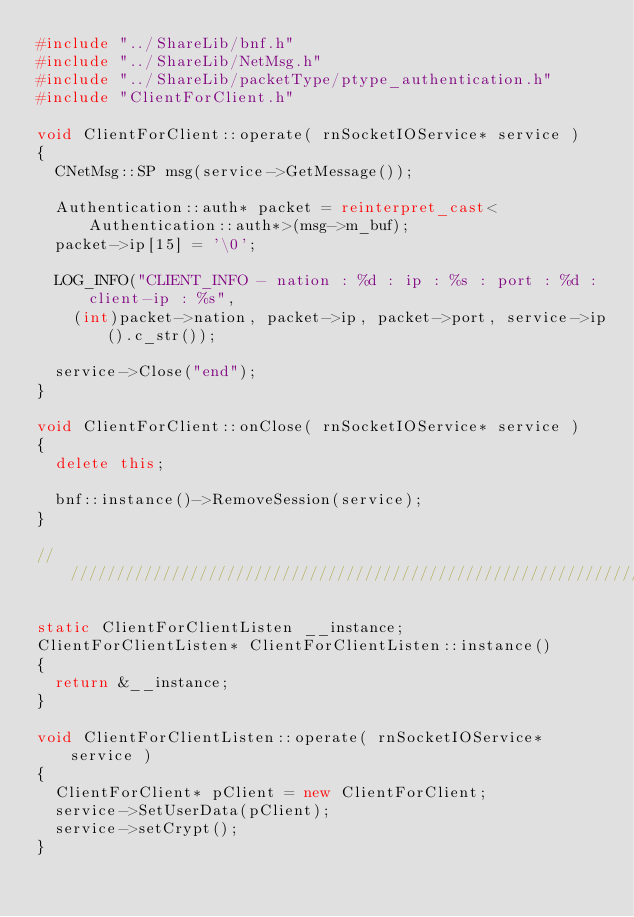<code> <loc_0><loc_0><loc_500><loc_500><_C++_>#include "../ShareLib/bnf.h"
#include "../ShareLib/NetMsg.h"
#include "../ShareLib/packetType/ptype_authentication.h"
#include "ClientForClient.h"

void ClientForClient::operate( rnSocketIOService* service )
{
	CNetMsg::SP msg(service->GetMessage());

	Authentication::auth* packet = reinterpret_cast<Authentication::auth*>(msg->m_buf);
	packet->ip[15] = '\0';

	LOG_INFO("CLIENT_INFO - nation : %d : ip : %s : port : %d : client-ip : %s",
		(int)packet->nation, packet->ip, packet->port, service->ip().c_str());

	service->Close("end");
}

void ClientForClient::onClose( rnSocketIOService* service )
{
	delete this;

	bnf::instance()->RemoveSession(service);
}

//////////////////////////////////////////////////////////////////////////

static ClientForClientListen __instance;
ClientForClientListen* ClientForClientListen::instance()
{
	return &__instance;
}

void ClientForClientListen::operate( rnSocketIOService* service )
{
	ClientForClient* pClient = new ClientForClient;
	service->SetUserData(pClient);
	service->setCrypt();
}
</code> 